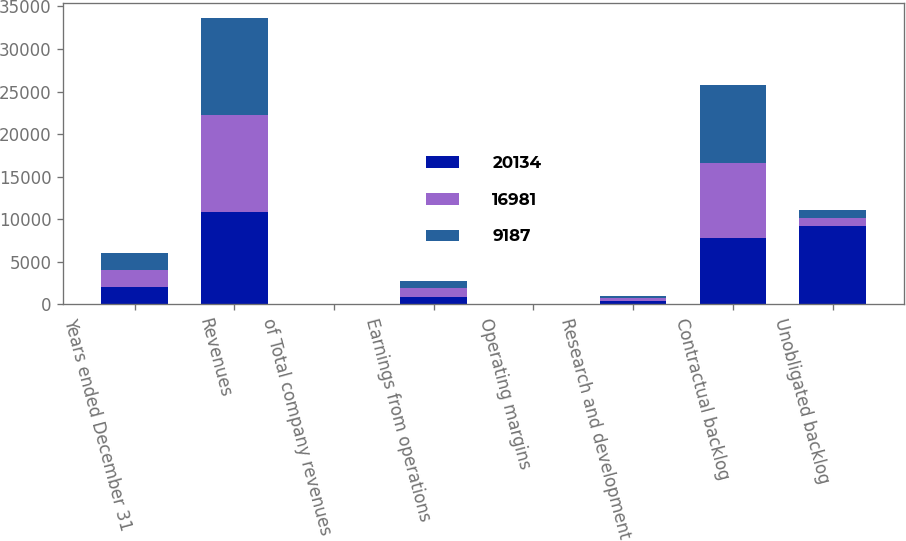<chart> <loc_0><loc_0><loc_500><loc_500><stacked_bar_chart><ecel><fcel>Years ended December 31<fcel>Revenues<fcel>of Total company revenues<fcel>Earnings from operations<fcel>Operating margins<fcel>Research and development<fcel>Contractual backlog<fcel>Unobligated backlog<nl><fcel>20134<fcel>2009<fcel>10877<fcel>16<fcel>839<fcel>7.7<fcel>397<fcel>7746<fcel>9187<nl><fcel>16981<fcel>2008<fcel>11346<fcel>19<fcel>1034<fcel>9.1<fcel>298<fcel>8868<fcel>948.5<nl><fcel>9187<fcel>2007<fcel>11481<fcel>17<fcel>863<fcel>7.5<fcel>289<fcel>9207<fcel>948.5<nl></chart> 